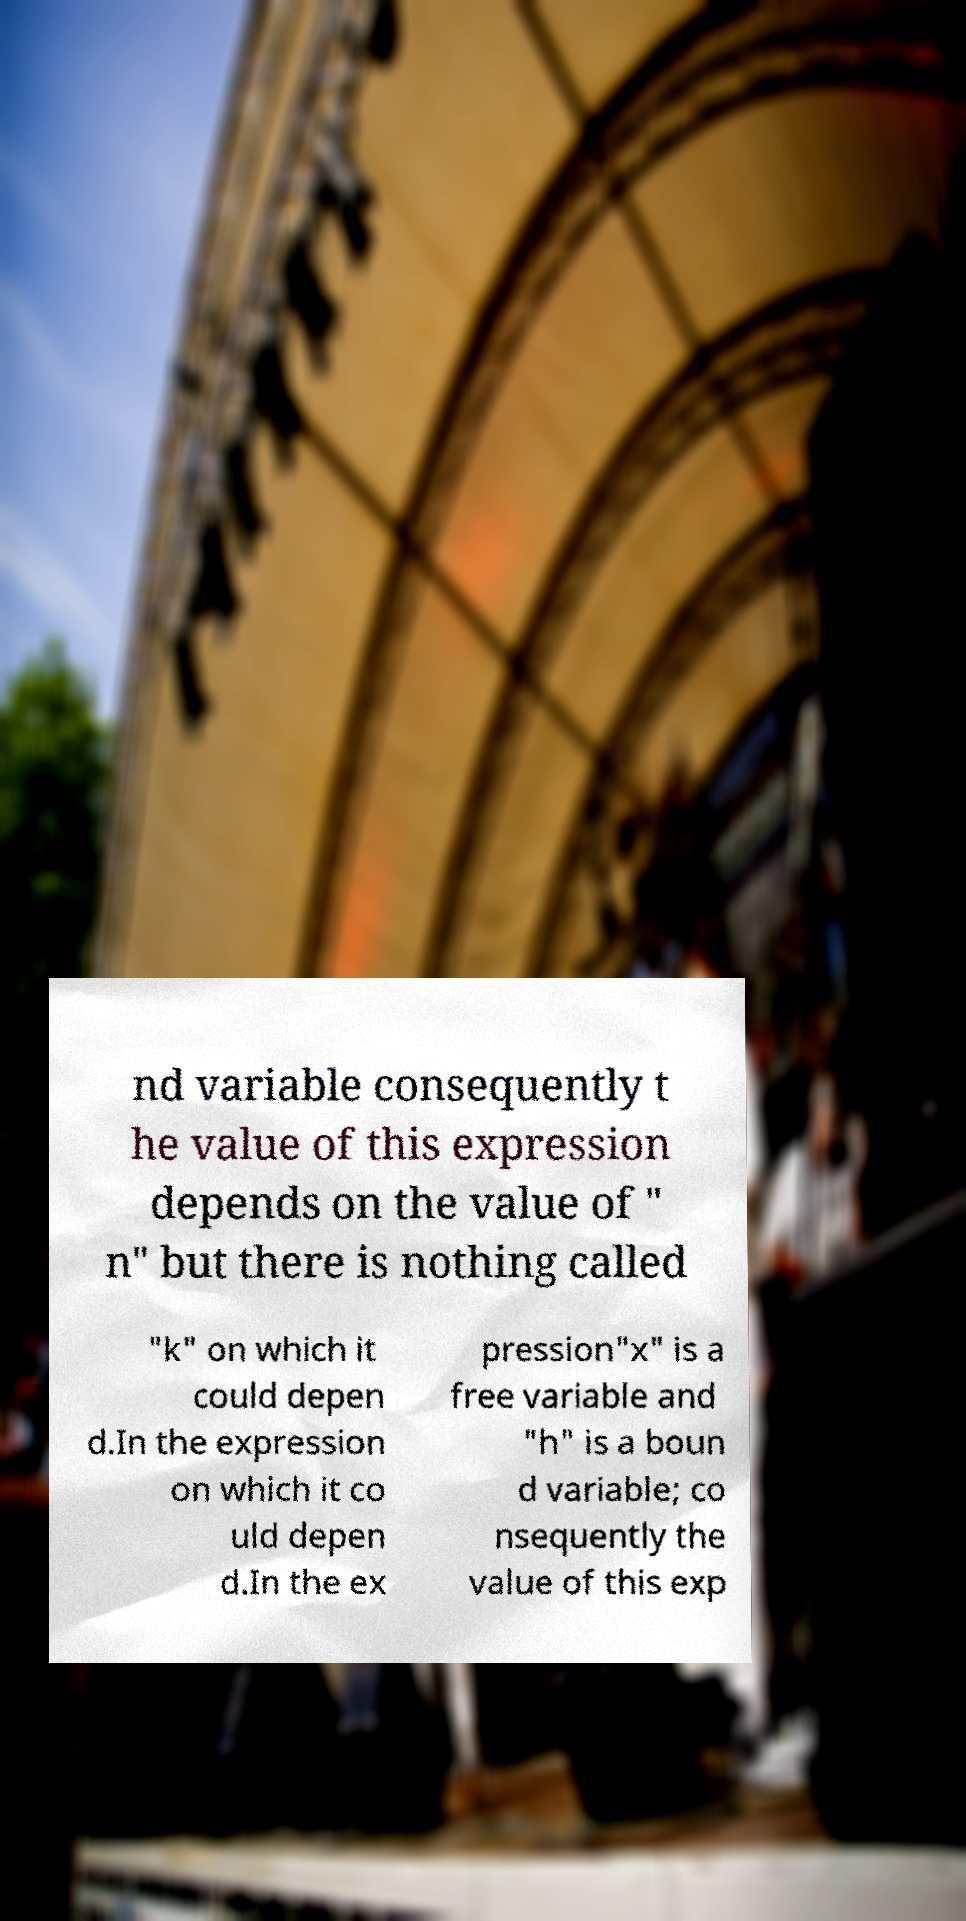Please identify and transcribe the text found in this image. nd variable consequently t he value of this expression depends on the value of " n" but there is nothing called "k" on which it could depen d.In the expression on which it co uld depen d.In the ex pression"x" is a free variable and "h" is a boun d variable; co nsequently the value of this exp 